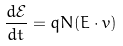Convert formula to latex. <formula><loc_0><loc_0><loc_500><loc_500>\frac { d \mathcal { E } } { d t } = q N ( E \cdot v )</formula> 